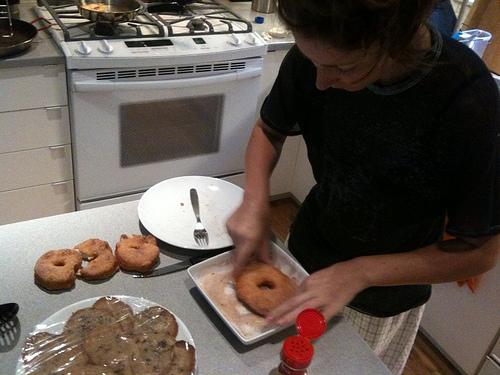Which object would you use to eat the food presented on the table? You would use the metallic grey fork. Describe the topping on the donuts and the type of container they are in. The donuts have a cinnamon topping, and they are placed in a white container. Identify the color and type of clothing the person in the image is wearing. The woman is wearing a black shirt. Explain what item on the table is red and plastic, and what is its purpose. The red plastic shaker top is used for seasoning or distributing spices. In a short sentence, describe the main actions of the woman in the photo. The woman is coating a doughnut with sugar. What kind of baked goods are inside a plastic wrap on a plate? Chocolate chip cookies are inside the plastic wrap. What is the color and type of the kitchen appliance in the image? It's a white and grey stove. Mention an object not related to the main food preparation scene and its color. There is a blue bottle cap in the background. List the types and colors of food items on the table. Three brown donuts, coated orange donuts, a brown cookie with dark chocolate chips. Describe a white kitchen item with two different functions shown in the image. A white stove with a pan on it is used for cooking, and it has a window in the oven for observation. 